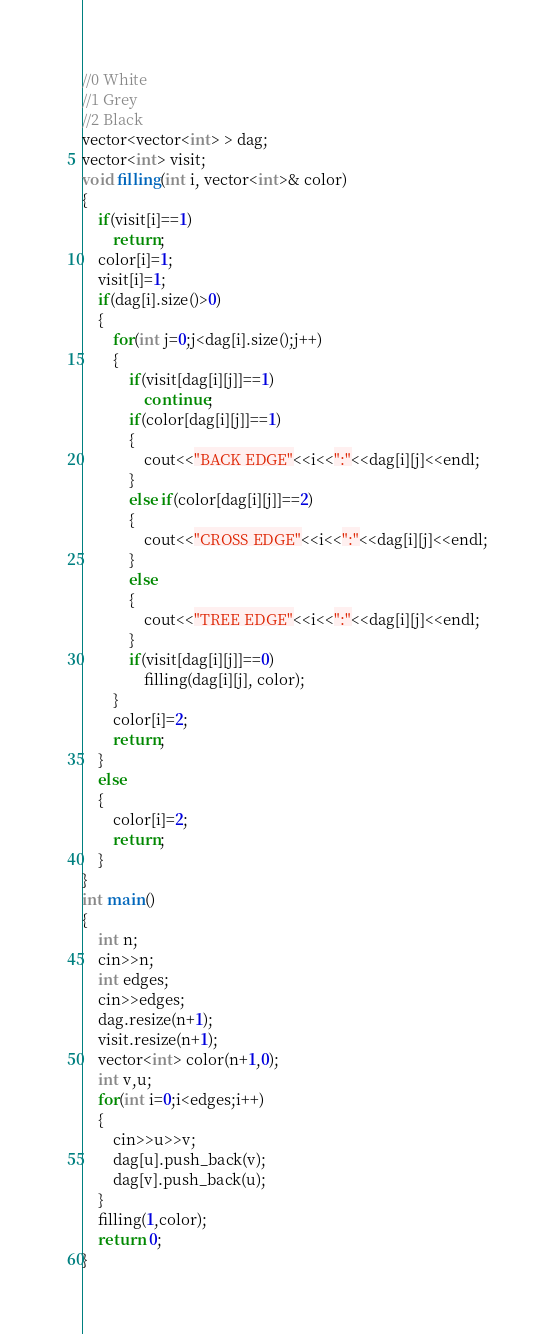<code> <loc_0><loc_0><loc_500><loc_500><_C++_>//0 White
//1 Grey
//2 Black
vector<vector<int> > dag;
vector<int> visit;
void filling(int i, vector<int>& color)
{
	if(visit[i]==1)
		return;
	color[i]=1;
	visit[i]=1;
	if(dag[i].size()>0)
	{
		for(int j=0;j<dag[i].size();j++)
		{
			if(visit[dag[i][j]]==1)
				continue;
			if(color[dag[i][j]]==1)
			{
				cout<<"BACK EDGE"<<i<<":"<<dag[i][j]<<endl;
			}
			else if(color[dag[i][j]]==2)
			{
				cout<<"CROSS EDGE"<<i<<":"<<dag[i][j]<<endl;
			}
			else
			{
				cout<<"TREE EDGE"<<i<<":"<<dag[i][j]<<endl;
			}
			if(visit[dag[i][j]]==0)
				filling(dag[i][j], color);
		}
		color[i]=2;
		return;
	}
	else
	{
		color[i]=2;
		return;
	}
}
int main()
{
	int n;
	cin>>n;
	int edges;
	cin>>edges;
	dag.resize(n+1);
	visit.resize(n+1);
	vector<int> color(n+1,0);
	int v,u;
	for(int i=0;i<edges;i++)
	{
		cin>>u>>v;
		dag[u].push_back(v);
		dag[v].push_back(u);
	}
	filling(1,color);
	return 0;
}</code> 